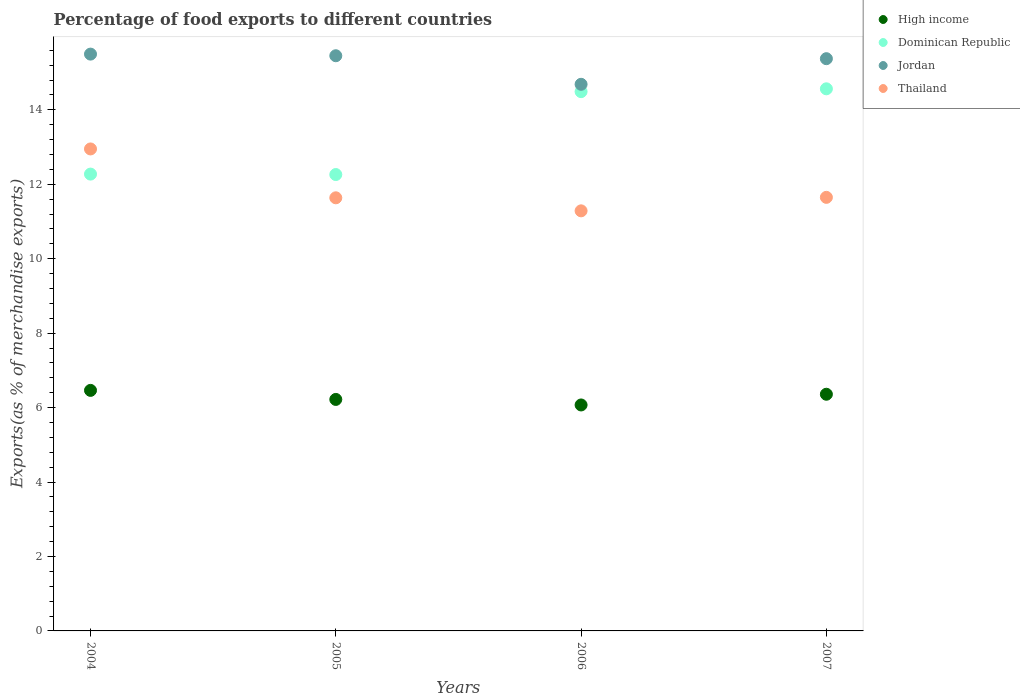How many different coloured dotlines are there?
Offer a very short reply. 4. What is the percentage of exports to different countries in Thailand in 2005?
Offer a very short reply. 11.64. Across all years, what is the maximum percentage of exports to different countries in Jordan?
Your answer should be compact. 15.5. Across all years, what is the minimum percentage of exports to different countries in Dominican Republic?
Your answer should be very brief. 12.26. What is the total percentage of exports to different countries in Jordan in the graph?
Provide a succinct answer. 61.01. What is the difference between the percentage of exports to different countries in Jordan in 2005 and that in 2006?
Ensure brevity in your answer.  0.77. What is the difference between the percentage of exports to different countries in Thailand in 2004 and the percentage of exports to different countries in High income in 2005?
Your answer should be very brief. 6.73. What is the average percentage of exports to different countries in Dominican Republic per year?
Your answer should be compact. 13.4. In the year 2005, what is the difference between the percentage of exports to different countries in Dominican Republic and percentage of exports to different countries in High income?
Your answer should be very brief. 6.04. What is the ratio of the percentage of exports to different countries in High income in 2006 to that in 2007?
Make the answer very short. 0.95. Is the percentage of exports to different countries in Dominican Republic in 2004 less than that in 2006?
Offer a very short reply. Yes. What is the difference between the highest and the second highest percentage of exports to different countries in Thailand?
Give a very brief answer. 1.3. What is the difference between the highest and the lowest percentage of exports to different countries in High income?
Provide a short and direct response. 0.39. Does the percentage of exports to different countries in Jordan monotonically increase over the years?
Ensure brevity in your answer.  No. Is the percentage of exports to different countries in Dominican Republic strictly greater than the percentage of exports to different countries in Jordan over the years?
Provide a short and direct response. No. What is the difference between two consecutive major ticks on the Y-axis?
Your answer should be compact. 2. Does the graph contain any zero values?
Your answer should be very brief. No. Does the graph contain grids?
Offer a very short reply. No. Where does the legend appear in the graph?
Provide a succinct answer. Top right. How are the legend labels stacked?
Ensure brevity in your answer.  Vertical. What is the title of the graph?
Provide a short and direct response. Percentage of food exports to different countries. What is the label or title of the Y-axis?
Ensure brevity in your answer.  Exports(as % of merchandise exports). What is the Exports(as % of merchandise exports) of High income in 2004?
Offer a terse response. 6.46. What is the Exports(as % of merchandise exports) in Dominican Republic in 2004?
Make the answer very short. 12.27. What is the Exports(as % of merchandise exports) of Jordan in 2004?
Offer a very short reply. 15.5. What is the Exports(as % of merchandise exports) of Thailand in 2004?
Ensure brevity in your answer.  12.95. What is the Exports(as % of merchandise exports) of High income in 2005?
Offer a terse response. 6.22. What is the Exports(as % of merchandise exports) of Dominican Republic in 2005?
Offer a terse response. 12.26. What is the Exports(as % of merchandise exports) in Jordan in 2005?
Ensure brevity in your answer.  15.45. What is the Exports(as % of merchandise exports) of Thailand in 2005?
Ensure brevity in your answer.  11.64. What is the Exports(as % of merchandise exports) in High income in 2006?
Your answer should be very brief. 6.07. What is the Exports(as % of merchandise exports) of Dominican Republic in 2006?
Keep it short and to the point. 14.49. What is the Exports(as % of merchandise exports) of Jordan in 2006?
Offer a terse response. 14.69. What is the Exports(as % of merchandise exports) of Thailand in 2006?
Make the answer very short. 11.29. What is the Exports(as % of merchandise exports) of High income in 2007?
Provide a short and direct response. 6.36. What is the Exports(as % of merchandise exports) in Dominican Republic in 2007?
Your answer should be very brief. 14.57. What is the Exports(as % of merchandise exports) of Jordan in 2007?
Keep it short and to the point. 15.37. What is the Exports(as % of merchandise exports) of Thailand in 2007?
Ensure brevity in your answer.  11.65. Across all years, what is the maximum Exports(as % of merchandise exports) of High income?
Give a very brief answer. 6.46. Across all years, what is the maximum Exports(as % of merchandise exports) of Dominican Republic?
Make the answer very short. 14.57. Across all years, what is the maximum Exports(as % of merchandise exports) of Jordan?
Provide a succinct answer. 15.5. Across all years, what is the maximum Exports(as % of merchandise exports) in Thailand?
Offer a very short reply. 12.95. Across all years, what is the minimum Exports(as % of merchandise exports) of High income?
Make the answer very short. 6.07. Across all years, what is the minimum Exports(as % of merchandise exports) in Dominican Republic?
Your response must be concise. 12.26. Across all years, what is the minimum Exports(as % of merchandise exports) of Jordan?
Keep it short and to the point. 14.69. Across all years, what is the minimum Exports(as % of merchandise exports) in Thailand?
Your answer should be compact. 11.29. What is the total Exports(as % of merchandise exports) of High income in the graph?
Offer a terse response. 25.11. What is the total Exports(as % of merchandise exports) of Dominican Republic in the graph?
Your response must be concise. 53.59. What is the total Exports(as % of merchandise exports) of Jordan in the graph?
Provide a succinct answer. 61.01. What is the total Exports(as % of merchandise exports) in Thailand in the graph?
Offer a very short reply. 47.52. What is the difference between the Exports(as % of merchandise exports) of High income in 2004 and that in 2005?
Your response must be concise. 0.24. What is the difference between the Exports(as % of merchandise exports) of Dominican Republic in 2004 and that in 2005?
Ensure brevity in your answer.  0.01. What is the difference between the Exports(as % of merchandise exports) in Jordan in 2004 and that in 2005?
Make the answer very short. 0.04. What is the difference between the Exports(as % of merchandise exports) in Thailand in 2004 and that in 2005?
Keep it short and to the point. 1.31. What is the difference between the Exports(as % of merchandise exports) in High income in 2004 and that in 2006?
Your answer should be very brief. 0.39. What is the difference between the Exports(as % of merchandise exports) of Dominican Republic in 2004 and that in 2006?
Offer a very short reply. -2.22. What is the difference between the Exports(as % of merchandise exports) in Jordan in 2004 and that in 2006?
Make the answer very short. 0.81. What is the difference between the Exports(as % of merchandise exports) in Thailand in 2004 and that in 2006?
Your answer should be compact. 1.66. What is the difference between the Exports(as % of merchandise exports) of High income in 2004 and that in 2007?
Your answer should be very brief. 0.1. What is the difference between the Exports(as % of merchandise exports) in Dominican Republic in 2004 and that in 2007?
Your answer should be compact. -2.29. What is the difference between the Exports(as % of merchandise exports) of Jordan in 2004 and that in 2007?
Your answer should be compact. 0.12. What is the difference between the Exports(as % of merchandise exports) of Thailand in 2004 and that in 2007?
Provide a short and direct response. 1.3. What is the difference between the Exports(as % of merchandise exports) of High income in 2005 and that in 2006?
Provide a short and direct response. 0.15. What is the difference between the Exports(as % of merchandise exports) in Dominican Republic in 2005 and that in 2006?
Provide a succinct answer. -2.23. What is the difference between the Exports(as % of merchandise exports) in Jordan in 2005 and that in 2006?
Make the answer very short. 0.77. What is the difference between the Exports(as % of merchandise exports) in Thailand in 2005 and that in 2006?
Your answer should be very brief. 0.35. What is the difference between the Exports(as % of merchandise exports) of High income in 2005 and that in 2007?
Keep it short and to the point. -0.14. What is the difference between the Exports(as % of merchandise exports) of Dominican Republic in 2005 and that in 2007?
Ensure brevity in your answer.  -2.3. What is the difference between the Exports(as % of merchandise exports) of Jordan in 2005 and that in 2007?
Make the answer very short. 0.08. What is the difference between the Exports(as % of merchandise exports) in Thailand in 2005 and that in 2007?
Your answer should be compact. -0.01. What is the difference between the Exports(as % of merchandise exports) of High income in 2006 and that in 2007?
Your answer should be compact. -0.29. What is the difference between the Exports(as % of merchandise exports) in Dominican Republic in 2006 and that in 2007?
Your response must be concise. -0.08. What is the difference between the Exports(as % of merchandise exports) in Jordan in 2006 and that in 2007?
Keep it short and to the point. -0.69. What is the difference between the Exports(as % of merchandise exports) of Thailand in 2006 and that in 2007?
Your response must be concise. -0.36. What is the difference between the Exports(as % of merchandise exports) in High income in 2004 and the Exports(as % of merchandise exports) in Dominican Republic in 2005?
Give a very brief answer. -5.8. What is the difference between the Exports(as % of merchandise exports) of High income in 2004 and the Exports(as % of merchandise exports) of Jordan in 2005?
Your answer should be compact. -8.99. What is the difference between the Exports(as % of merchandise exports) in High income in 2004 and the Exports(as % of merchandise exports) in Thailand in 2005?
Offer a very short reply. -5.17. What is the difference between the Exports(as % of merchandise exports) in Dominican Republic in 2004 and the Exports(as % of merchandise exports) in Jordan in 2005?
Your response must be concise. -3.18. What is the difference between the Exports(as % of merchandise exports) of Dominican Republic in 2004 and the Exports(as % of merchandise exports) of Thailand in 2005?
Make the answer very short. 0.64. What is the difference between the Exports(as % of merchandise exports) in Jordan in 2004 and the Exports(as % of merchandise exports) in Thailand in 2005?
Provide a short and direct response. 3.86. What is the difference between the Exports(as % of merchandise exports) of High income in 2004 and the Exports(as % of merchandise exports) of Dominican Republic in 2006?
Make the answer very short. -8.03. What is the difference between the Exports(as % of merchandise exports) in High income in 2004 and the Exports(as % of merchandise exports) in Jordan in 2006?
Keep it short and to the point. -8.22. What is the difference between the Exports(as % of merchandise exports) of High income in 2004 and the Exports(as % of merchandise exports) of Thailand in 2006?
Provide a succinct answer. -4.82. What is the difference between the Exports(as % of merchandise exports) of Dominican Republic in 2004 and the Exports(as % of merchandise exports) of Jordan in 2006?
Keep it short and to the point. -2.41. What is the difference between the Exports(as % of merchandise exports) in Dominican Republic in 2004 and the Exports(as % of merchandise exports) in Thailand in 2006?
Keep it short and to the point. 0.99. What is the difference between the Exports(as % of merchandise exports) in Jordan in 2004 and the Exports(as % of merchandise exports) in Thailand in 2006?
Make the answer very short. 4.21. What is the difference between the Exports(as % of merchandise exports) in High income in 2004 and the Exports(as % of merchandise exports) in Dominican Republic in 2007?
Ensure brevity in your answer.  -8.1. What is the difference between the Exports(as % of merchandise exports) of High income in 2004 and the Exports(as % of merchandise exports) of Jordan in 2007?
Ensure brevity in your answer.  -8.91. What is the difference between the Exports(as % of merchandise exports) in High income in 2004 and the Exports(as % of merchandise exports) in Thailand in 2007?
Your answer should be very brief. -5.19. What is the difference between the Exports(as % of merchandise exports) in Dominican Republic in 2004 and the Exports(as % of merchandise exports) in Jordan in 2007?
Provide a short and direct response. -3.1. What is the difference between the Exports(as % of merchandise exports) in Dominican Republic in 2004 and the Exports(as % of merchandise exports) in Thailand in 2007?
Your answer should be compact. 0.62. What is the difference between the Exports(as % of merchandise exports) in Jordan in 2004 and the Exports(as % of merchandise exports) in Thailand in 2007?
Your response must be concise. 3.85. What is the difference between the Exports(as % of merchandise exports) of High income in 2005 and the Exports(as % of merchandise exports) of Dominican Republic in 2006?
Your response must be concise. -8.27. What is the difference between the Exports(as % of merchandise exports) of High income in 2005 and the Exports(as % of merchandise exports) of Jordan in 2006?
Make the answer very short. -8.47. What is the difference between the Exports(as % of merchandise exports) in High income in 2005 and the Exports(as % of merchandise exports) in Thailand in 2006?
Offer a very short reply. -5.07. What is the difference between the Exports(as % of merchandise exports) of Dominican Republic in 2005 and the Exports(as % of merchandise exports) of Jordan in 2006?
Provide a short and direct response. -2.42. What is the difference between the Exports(as % of merchandise exports) of Dominican Republic in 2005 and the Exports(as % of merchandise exports) of Thailand in 2006?
Keep it short and to the point. 0.98. What is the difference between the Exports(as % of merchandise exports) in Jordan in 2005 and the Exports(as % of merchandise exports) in Thailand in 2006?
Provide a short and direct response. 4.17. What is the difference between the Exports(as % of merchandise exports) in High income in 2005 and the Exports(as % of merchandise exports) in Dominican Republic in 2007?
Your answer should be very brief. -8.35. What is the difference between the Exports(as % of merchandise exports) of High income in 2005 and the Exports(as % of merchandise exports) of Jordan in 2007?
Offer a terse response. -9.15. What is the difference between the Exports(as % of merchandise exports) in High income in 2005 and the Exports(as % of merchandise exports) in Thailand in 2007?
Your answer should be very brief. -5.43. What is the difference between the Exports(as % of merchandise exports) in Dominican Republic in 2005 and the Exports(as % of merchandise exports) in Jordan in 2007?
Ensure brevity in your answer.  -3.11. What is the difference between the Exports(as % of merchandise exports) in Dominican Republic in 2005 and the Exports(as % of merchandise exports) in Thailand in 2007?
Offer a very short reply. 0.61. What is the difference between the Exports(as % of merchandise exports) in Jordan in 2005 and the Exports(as % of merchandise exports) in Thailand in 2007?
Offer a very short reply. 3.8. What is the difference between the Exports(as % of merchandise exports) in High income in 2006 and the Exports(as % of merchandise exports) in Dominican Republic in 2007?
Your answer should be compact. -8.49. What is the difference between the Exports(as % of merchandise exports) of High income in 2006 and the Exports(as % of merchandise exports) of Jordan in 2007?
Provide a succinct answer. -9.3. What is the difference between the Exports(as % of merchandise exports) of High income in 2006 and the Exports(as % of merchandise exports) of Thailand in 2007?
Make the answer very short. -5.58. What is the difference between the Exports(as % of merchandise exports) of Dominican Republic in 2006 and the Exports(as % of merchandise exports) of Jordan in 2007?
Your answer should be very brief. -0.89. What is the difference between the Exports(as % of merchandise exports) of Dominican Republic in 2006 and the Exports(as % of merchandise exports) of Thailand in 2007?
Your response must be concise. 2.84. What is the difference between the Exports(as % of merchandise exports) in Jordan in 2006 and the Exports(as % of merchandise exports) in Thailand in 2007?
Give a very brief answer. 3.04. What is the average Exports(as % of merchandise exports) in High income per year?
Your response must be concise. 6.28. What is the average Exports(as % of merchandise exports) in Dominican Republic per year?
Offer a terse response. 13.4. What is the average Exports(as % of merchandise exports) of Jordan per year?
Offer a very short reply. 15.25. What is the average Exports(as % of merchandise exports) of Thailand per year?
Keep it short and to the point. 11.88. In the year 2004, what is the difference between the Exports(as % of merchandise exports) in High income and Exports(as % of merchandise exports) in Dominican Republic?
Your answer should be very brief. -5.81. In the year 2004, what is the difference between the Exports(as % of merchandise exports) of High income and Exports(as % of merchandise exports) of Jordan?
Offer a terse response. -9.03. In the year 2004, what is the difference between the Exports(as % of merchandise exports) of High income and Exports(as % of merchandise exports) of Thailand?
Give a very brief answer. -6.49. In the year 2004, what is the difference between the Exports(as % of merchandise exports) in Dominican Republic and Exports(as % of merchandise exports) in Jordan?
Your answer should be compact. -3.22. In the year 2004, what is the difference between the Exports(as % of merchandise exports) in Dominican Republic and Exports(as % of merchandise exports) in Thailand?
Make the answer very short. -0.68. In the year 2004, what is the difference between the Exports(as % of merchandise exports) in Jordan and Exports(as % of merchandise exports) in Thailand?
Your answer should be compact. 2.55. In the year 2005, what is the difference between the Exports(as % of merchandise exports) in High income and Exports(as % of merchandise exports) in Dominican Republic?
Offer a very short reply. -6.04. In the year 2005, what is the difference between the Exports(as % of merchandise exports) in High income and Exports(as % of merchandise exports) in Jordan?
Keep it short and to the point. -9.23. In the year 2005, what is the difference between the Exports(as % of merchandise exports) of High income and Exports(as % of merchandise exports) of Thailand?
Offer a terse response. -5.42. In the year 2005, what is the difference between the Exports(as % of merchandise exports) in Dominican Republic and Exports(as % of merchandise exports) in Jordan?
Your response must be concise. -3.19. In the year 2005, what is the difference between the Exports(as % of merchandise exports) in Dominican Republic and Exports(as % of merchandise exports) in Thailand?
Your answer should be compact. 0.63. In the year 2005, what is the difference between the Exports(as % of merchandise exports) of Jordan and Exports(as % of merchandise exports) of Thailand?
Give a very brief answer. 3.82. In the year 2006, what is the difference between the Exports(as % of merchandise exports) of High income and Exports(as % of merchandise exports) of Dominican Republic?
Ensure brevity in your answer.  -8.42. In the year 2006, what is the difference between the Exports(as % of merchandise exports) of High income and Exports(as % of merchandise exports) of Jordan?
Your response must be concise. -8.62. In the year 2006, what is the difference between the Exports(as % of merchandise exports) of High income and Exports(as % of merchandise exports) of Thailand?
Make the answer very short. -5.22. In the year 2006, what is the difference between the Exports(as % of merchandise exports) in Dominican Republic and Exports(as % of merchandise exports) in Jordan?
Provide a succinct answer. -0.2. In the year 2006, what is the difference between the Exports(as % of merchandise exports) in Dominican Republic and Exports(as % of merchandise exports) in Thailand?
Provide a succinct answer. 3.2. In the year 2006, what is the difference between the Exports(as % of merchandise exports) of Jordan and Exports(as % of merchandise exports) of Thailand?
Provide a short and direct response. 3.4. In the year 2007, what is the difference between the Exports(as % of merchandise exports) of High income and Exports(as % of merchandise exports) of Dominican Republic?
Make the answer very short. -8.21. In the year 2007, what is the difference between the Exports(as % of merchandise exports) in High income and Exports(as % of merchandise exports) in Jordan?
Keep it short and to the point. -9.02. In the year 2007, what is the difference between the Exports(as % of merchandise exports) of High income and Exports(as % of merchandise exports) of Thailand?
Keep it short and to the point. -5.29. In the year 2007, what is the difference between the Exports(as % of merchandise exports) of Dominican Republic and Exports(as % of merchandise exports) of Jordan?
Give a very brief answer. -0.81. In the year 2007, what is the difference between the Exports(as % of merchandise exports) in Dominican Republic and Exports(as % of merchandise exports) in Thailand?
Offer a terse response. 2.92. In the year 2007, what is the difference between the Exports(as % of merchandise exports) of Jordan and Exports(as % of merchandise exports) of Thailand?
Your answer should be very brief. 3.73. What is the ratio of the Exports(as % of merchandise exports) in High income in 2004 to that in 2005?
Offer a very short reply. 1.04. What is the ratio of the Exports(as % of merchandise exports) of Jordan in 2004 to that in 2005?
Your response must be concise. 1. What is the ratio of the Exports(as % of merchandise exports) of Thailand in 2004 to that in 2005?
Keep it short and to the point. 1.11. What is the ratio of the Exports(as % of merchandise exports) of High income in 2004 to that in 2006?
Keep it short and to the point. 1.06. What is the ratio of the Exports(as % of merchandise exports) in Dominican Republic in 2004 to that in 2006?
Keep it short and to the point. 0.85. What is the ratio of the Exports(as % of merchandise exports) in Jordan in 2004 to that in 2006?
Provide a succinct answer. 1.06. What is the ratio of the Exports(as % of merchandise exports) of Thailand in 2004 to that in 2006?
Provide a short and direct response. 1.15. What is the ratio of the Exports(as % of merchandise exports) in High income in 2004 to that in 2007?
Keep it short and to the point. 1.02. What is the ratio of the Exports(as % of merchandise exports) of Dominican Republic in 2004 to that in 2007?
Offer a terse response. 0.84. What is the ratio of the Exports(as % of merchandise exports) of Thailand in 2004 to that in 2007?
Provide a short and direct response. 1.11. What is the ratio of the Exports(as % of merchandise exports) of High income in 2005 to that in 2006?
Keep it short and to the point. 1.02. What is the ratio of the Exports(as % of merchandise exports) in Dominican Republic in 2005 to that in 2006?
Keep it short and to the point. 0.85. What is the ratio of the Exports(as % of merchandise exports) in Jordan in 2005 to that in 2006?
Provide a succinct answer. 1.05. What is the ratio of the Exports(as % of merchandise exports) in Thailand in 2005 to that in 2006?
Your answer should be very brief. 1.03. What is the ratio of the Exports(as % of merchandise exports) of High income in 2005 to that in 2007?
Make the answer very short. 0.98. What is the ratio of the Exports(as % of merchandise exports) in Dominican Republic in 2005 to that in 2007?
Give a very brief answer. 0.84. What is the ratio of the Exports(as % of merchandise exports) of Jordan in 2005 to that in 2007?
Ensure brevity in your answer.  1.01. What is the ratio of the Exports(as % of merchandise exports) of High income in 2006 to that in 2007?
Your answer should be very brief. 0.95. What is the ratio of the Exports(as % of merchandise exports) of Jordan in 2006 to that in 2007?
Your answer should be very brief. 0.96. What is the ratio of the Exports(as % of merchandise exports) in Thailand in 2006 to that in 2007?
Your response must be concise. 0.97. What is the difference between the highest and the second highest Exports(as % of merchandise exports) in High income?
Provide a short and direct response. 0.1. What is the difference between the highest and the second highest Exports(as % of merchandise exports) in Dominican Republic?
Ensure brevity in your answer.  0.08. What is the difference between the highest and the second highest Exports(as % of merchandise exports) of Jordan?
Your response must be concise. 0.04. What is the difference between the highest and the second highest Exports(as % of merchandise exports) of Thailand?
Your answer should be compact. 1.3. What is the difference between the highest and the lowest Exports(as % of merchandise exports) of High income?
Offer a terse response. 0.39. What is the difference between the highest and the lowest Exports(as % of merchandise exports) in Dominican Republic?
Ensure brevity in your answer.  2.3. What is the difference between the highest and the lowest Exports(as % of merchandise exports) of Jordan?
Your answer should be compact. 0.81. What is the difference between the highest and the lowest Exports(as % of merchandise exports) of Thailand?
Offer a very short reply. 1.66. 